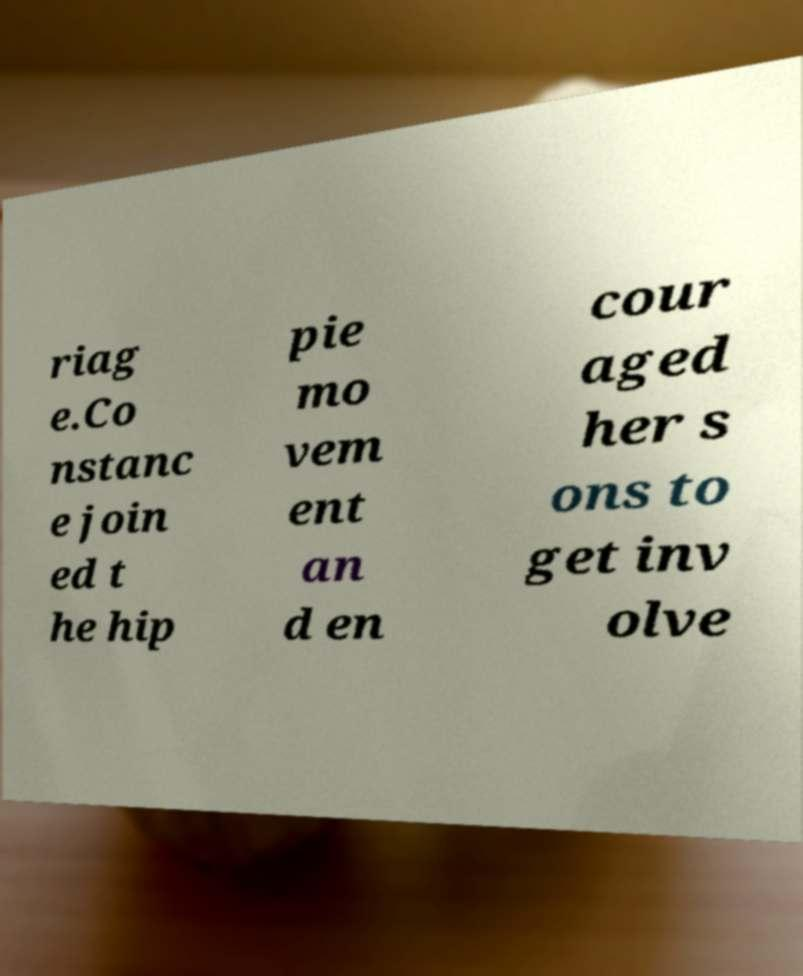Can you accurately transcribe the text from the provided image for me? riag e.Co nstanc e join ed t he hip pie mo vem ent an d en cour aged her s ons to get inv olve 